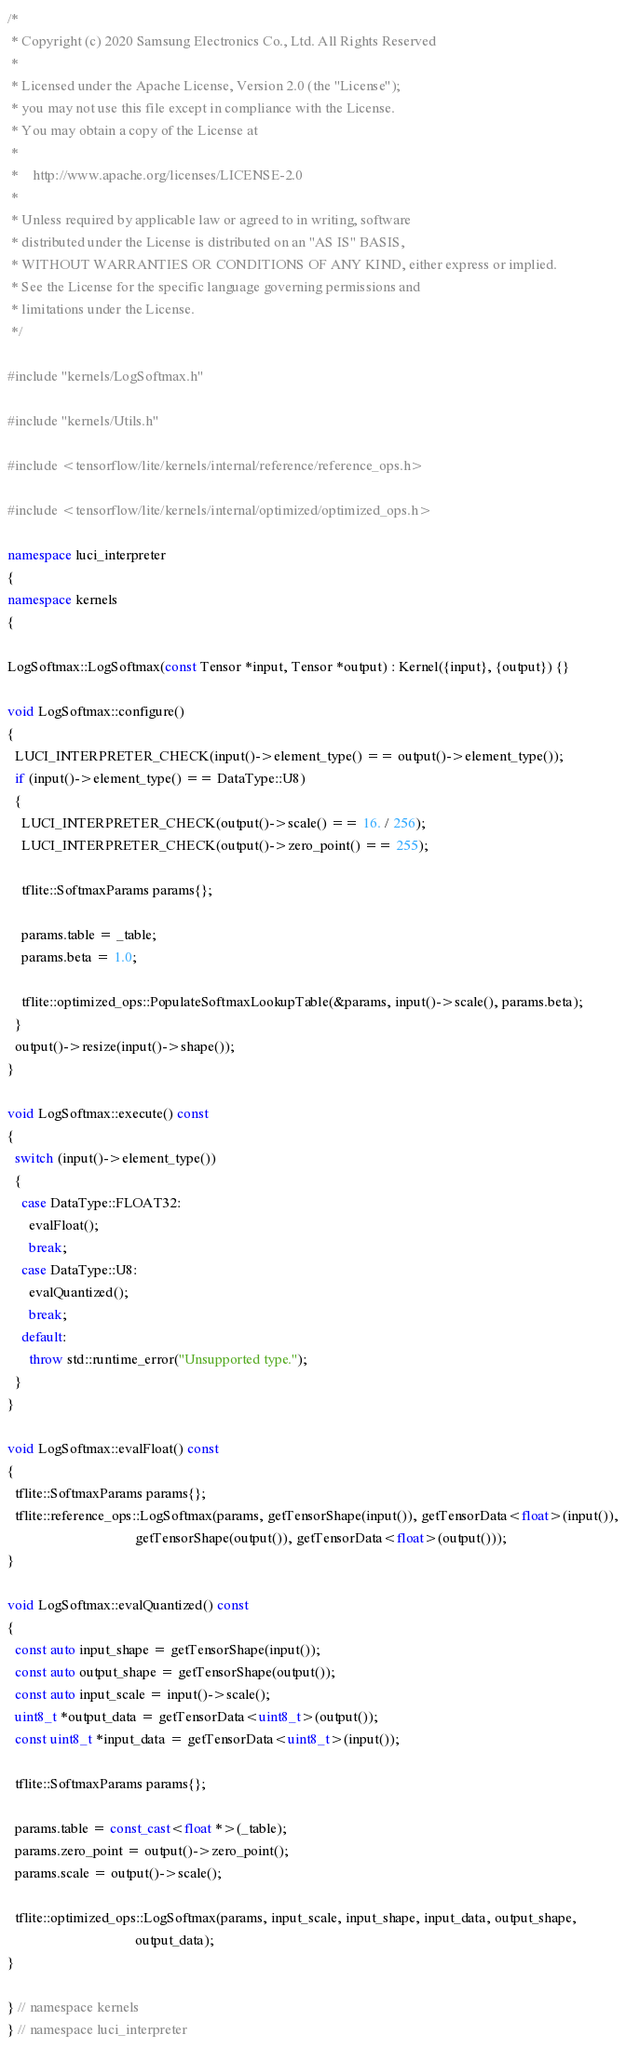<code> <loc_0><loc_0><loc_500><loc_500><_C++_>/*
 * Copyright (c) 2020 Samsung Electronics Co., Ltd. All Rights Reserved
 *
 * Licensed under the Apache License, Version 2.0 (the "License");
 * you may not use this file except in compliance with the License.
 * You may obtain a copy of the License at
 *
 *    http://www.apache.org/licenses/LICENSE-2.0
 *
 * Unless required by applicable law or agreed to in writing, software
 * distributed under the License is distributed on an "AS IS" BASIS,
 * WITHOUT WARRANTIES OR CONDITIONS OF ANY KIND, either express or implied.
 * See the License for the specific language governing permissions and
 * limitations under the License.
 */

#include "kernels/LogSoftmax.h"

#include "kernels/Utils.h"

#include <tensorflow/lite/kernels/internal/reference/reference_ops.h>

#include <tensorflow/lite/kernels/internal/optimized/optimized_ops.h>

namespace luci_interpreter
{
namespace kernels
{

LogSoftmax::LogSoftmax(const Tensor *input, Tensor *output) : Kernel({input}, {output}) {}

void LogSoftmax::configure()
{
  LUCI_INTERPRETER_CHECK(input()->element_type() == output()->element_type());
  if (input()->element_type() == DataType::U8)
  {
    LUCI_INTERPRETER_CHECK(output()->scale() == 16. / 256);
    LUCI_INTERPRETER_CHECK(output()->zero_point() == 255);

    tflite::SoftmaxParams params{};

    params.table = _table;
    params.beta = 1.0;

    tflite::optimized_ops::PopulateSoftmaxLookupTable(&params, input()->scale(), params.beta);
  }
  output()->resize(input()->shape());
}

void LogSoftmax::execute() const
{
  switch (input()->element_type())
  {
    case DataType::FLOAT32:
      evalFloat();
      break;
    case DataType::U8:
      evalQuantized();
      break;
    default:
      throw std::runtime_error("Unsupported type.");
  }
}

void LogSoftmax::evalFloat() const
{
  tflite::SoftmaxParams params{};
  tflite::reference_ops::LogSoftmax(params, getTensorShape(input()), getTensorData<float>(input()),
                                    getTensorShape(output()), getTensorData<float>(output()));
}

void LogSoftmax::evalQuantized() const
{
  const auto input_shape = getTensorShape(input());
  const auto output_shape = getTensorShape(output());
  const auto input_scale = input()->scale();
  uint8_t *output_data = getTensorData<uint8_t>(output());
  const uint8_t *input_data = getTensorData<uint8_t>(input());

  tflite::SoftmaxParams params{};

  params.table = const_cast<float *>(_table);
  params.zero_point = output()->zero_point();
  params.scale = output()->scale();

  tflite::optimized_ops::LogSoftmax(params, input_scale, input_shape, input_data, output_shape,
                                    output_data);
}

} // namespace kernels
} // namespace luci_interpreter
</code> 